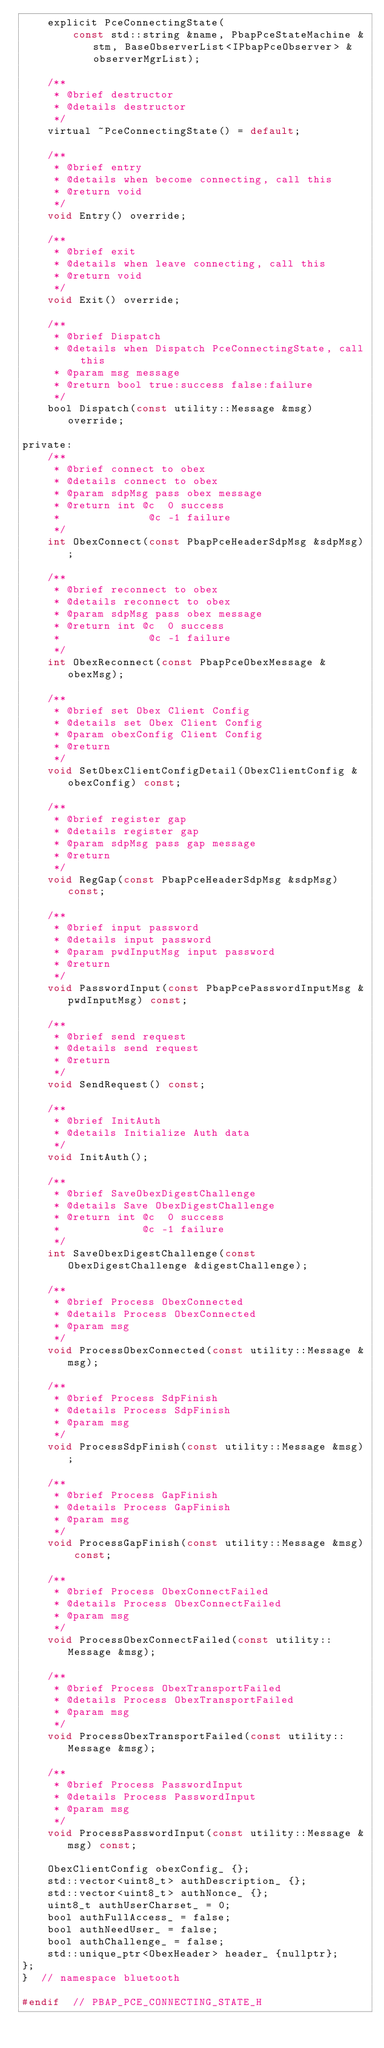<code> <loc_0><loc_0><loc_500><loc_500><_C_>    explicit PceConnectingState(
        const std::string &name, PbapPceStateMachine &stm, BaseObserverList<IPbapPceObserver> &observerMgrList);

    /**
     * @brief destructor
     * @details destructor
     */
    virtual ~PceConnectingState() = default;

    /**
     * @brief entry
     * @details when become connecting, call this
     * @return void
     */
    void Entry() override;

    /**
     * @brief exit
     * @details when leave connecting, call this
     * @return void
     */
    void Exit() override;

    /**
     * @brief Dispatch
     * @details when Dispatch PceConnectingState, call this
     * @param msg message
     * @return bool true:success false:failure
     */
    bool Dispatch(const utility::Message &msg) override;

private:
    /**
     * @brief connect to obex
     * @details connect to obex
     * @param sdpMsg pass obex message
     * @return int @c  0 success
     *              @c -1 failure
     */
    int ObexConnect(const PbapPceHeaderSdpMsg &sdpMsg);

    /**
     * @brief reconnect to obex
     * @details reconnect to obex
     * @param sdpMsg pass obex message
     * @return int @c  0 success
     *              @c -1 failure
     */
    int ObexReconnect(const PbapPceObexMessage &obexMsg);

    /**
     * @brief set Obex Client Config
     * @details set Obex Client Config
     * @param obexConfig Client Config
     * @return
     */
    void SetObexClientConfigDetail(ObexClientConfig &obexConfig) const;

    /**
     * @brief register gap
     * @details register gap
     * @param sdpMsg pass gap message
     * @return
     */
    void RegGap(const PbapPceHeaderSdpMsg &sdpMsg) const;

    /**
     * @brief input password
     * @details input password
     * @param pwdInputMsg input password
     * @return
     */
    void PasswordInput(const PbapPcePasswordInputMsg &pwdInputMsg) const;

    /**
     * @brief send request
     * @details send request
     * @return
     */
    void SendRequest() const;

    /**
     * @brief InitAuth
     * @details Initialize Auth data
     */
    void InitAuth();

    /**
     * @brief SaveObexDigestChallenge
     * @details Save ObexDigestChallenge
     * @return int @c  0 success
     *             @c -1 failure
     */
    int SaveObexDigestChallenge(const ObexDigestChallenge &digestChallenge);

    /**
     * @brief Process ObexConnected
     * @details Process ObexConnected
     * @param msg
     */
    void ProcessObexConnected(const utility::Message &msg);

    /**
     * @brief Process SdpFinish
     * @details Process SdpFinish
     * @param msg
     */
    void ProcessSdpFinish(const utility::Message &msg);

    /**
     * @brief Process GapFinish
     * @details Process GapFinish
     * @param msg
     */
    void ProcessGapFinish(const utility::Message &msg) const;

    /**
     * @brief Process ObexConnectFailed
     * @details Process ObexConnectFailed
     * @param msg
     */
    void ProcessObexConnectFailed(const utility::Message &msg);

    /**
     * @brief Process ObexTransportFailed
     * @details Process ObexTransportFailed
     * @param msg
     */
    void ProcessObexTransportFailed(const utility::Message &msg);

    /**
     * @brief Process PasswordInput
     * @details Process PasswordInput
     * @param msg
     */
    void ProcessPasswordInput(const utility::Message &msg) const;

    ObexClientConfig obexConfig_ {};
    std::vector<uint8_t> authDescription_ {};
    std::vector<uint8_t> authNonce_ {};
    uint8_t authUserCharset_ = 0;
    bool authFullAccess_ = false;
    bool authNeedUser_ = false;
    bool authChallenge_ = false;
    std::unique_ptr<ObexHeader> header_ {nullptr};
};
}  // namespace bluetooth

#endif  // PBAP_PCE_CONNECTING_STATE_H
</code> 